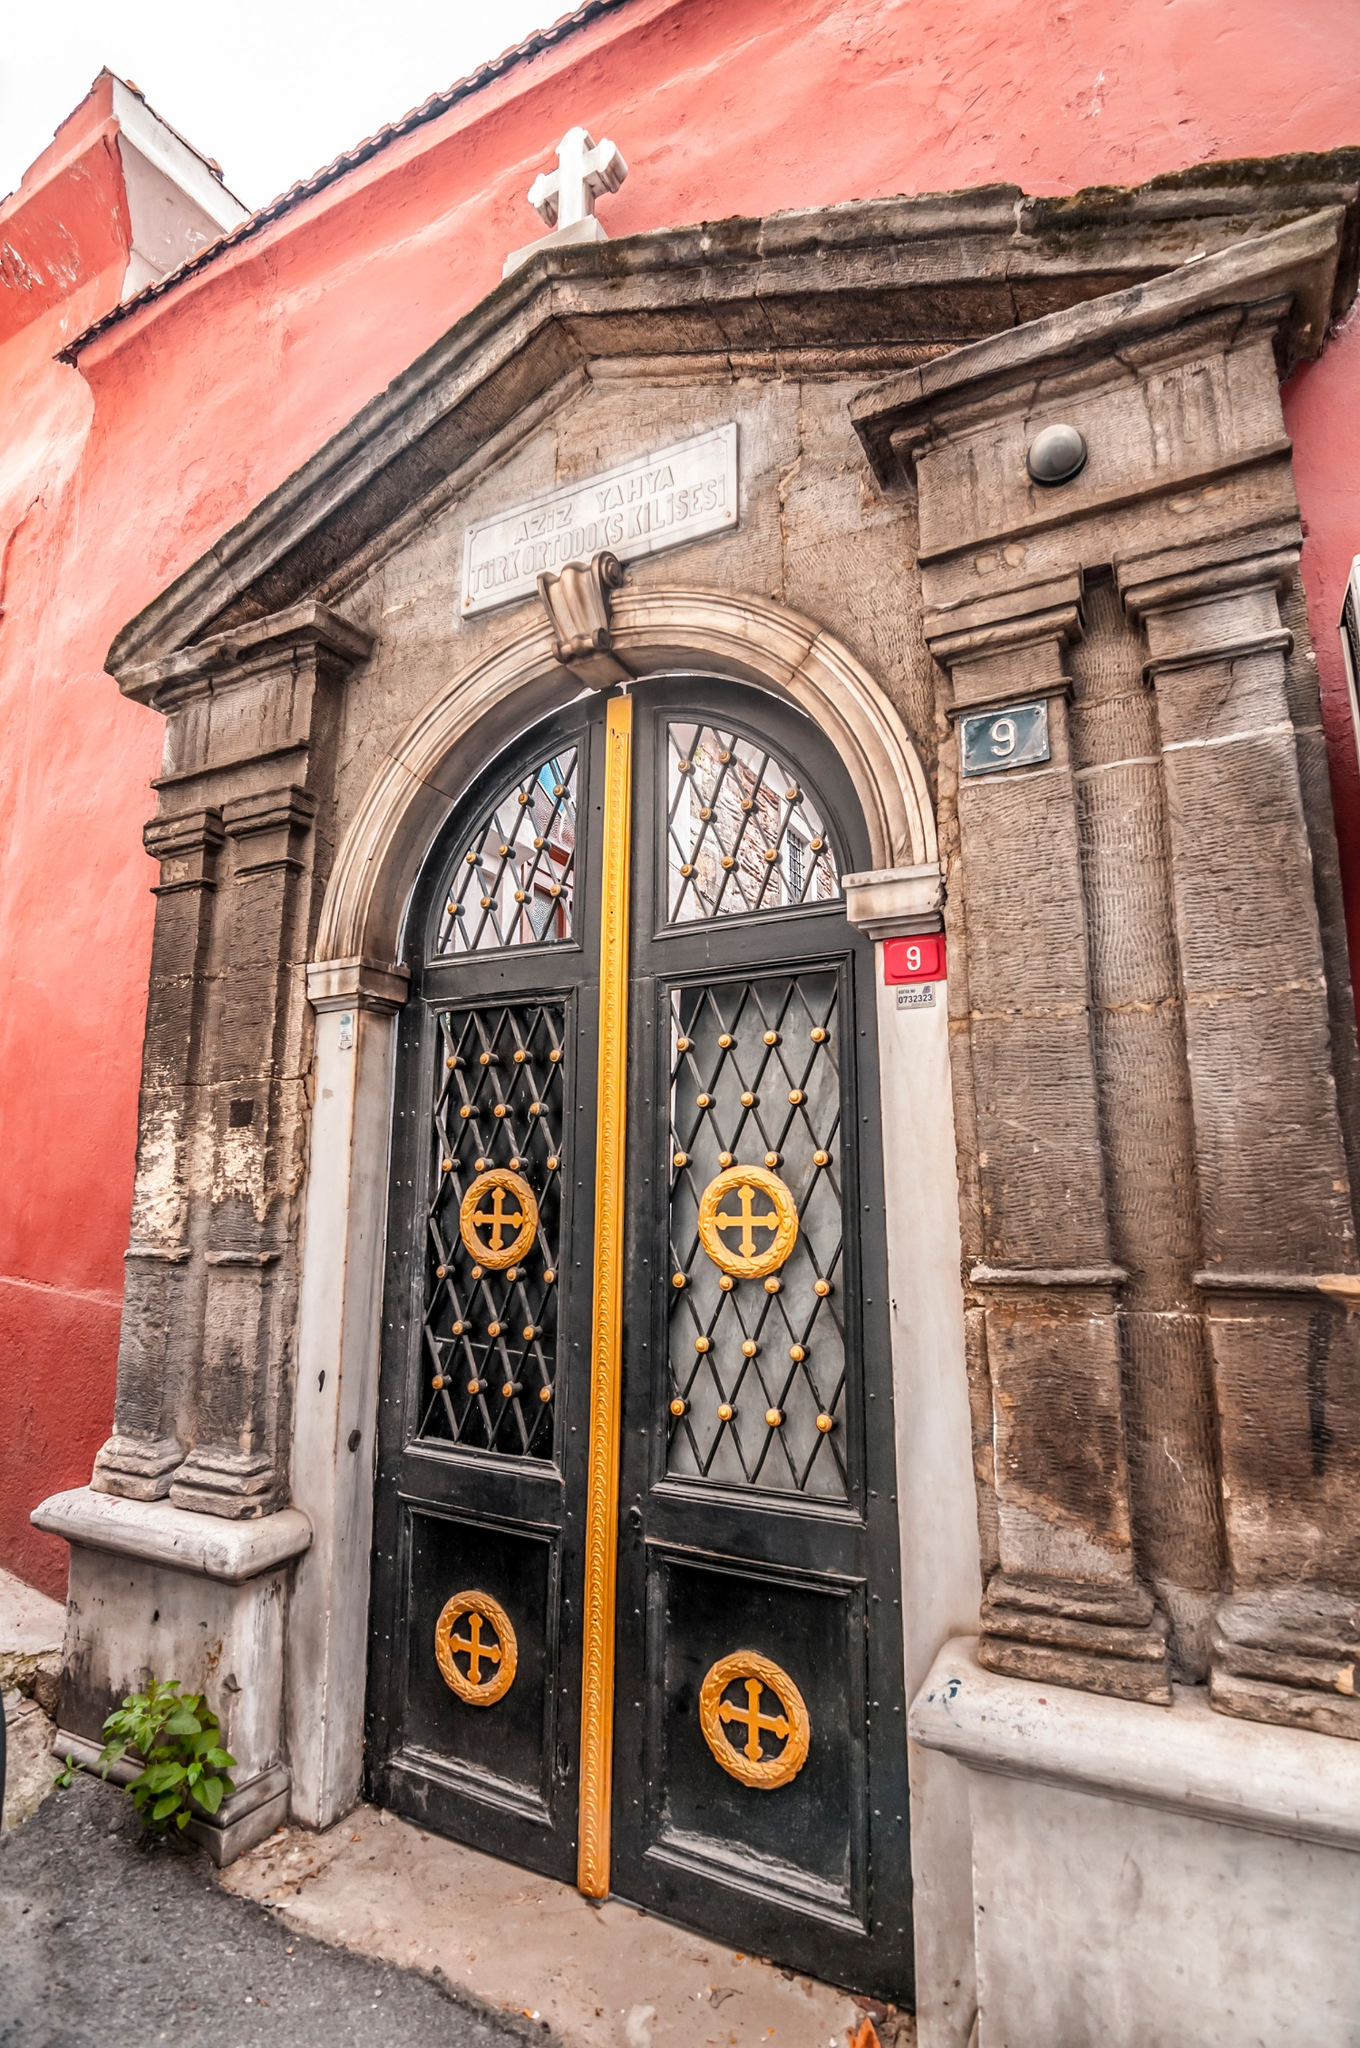If these walls could talk, what story would they tell? If these walls could talk, they would tell a story of centuries of faith and devotion. They would recount the multitude of prayers whispered through the iron gates, the joyous celebrations of weddings and baptisms, and the solemn farewells at funerals. They would speak of resilience, of how this building stood firm through the trials of time - wars, natural disasters, and social changes. These walls have witnessed the ebb and flow of generations, remaining a steadfast cornerstone of the community’s spiritual life. 